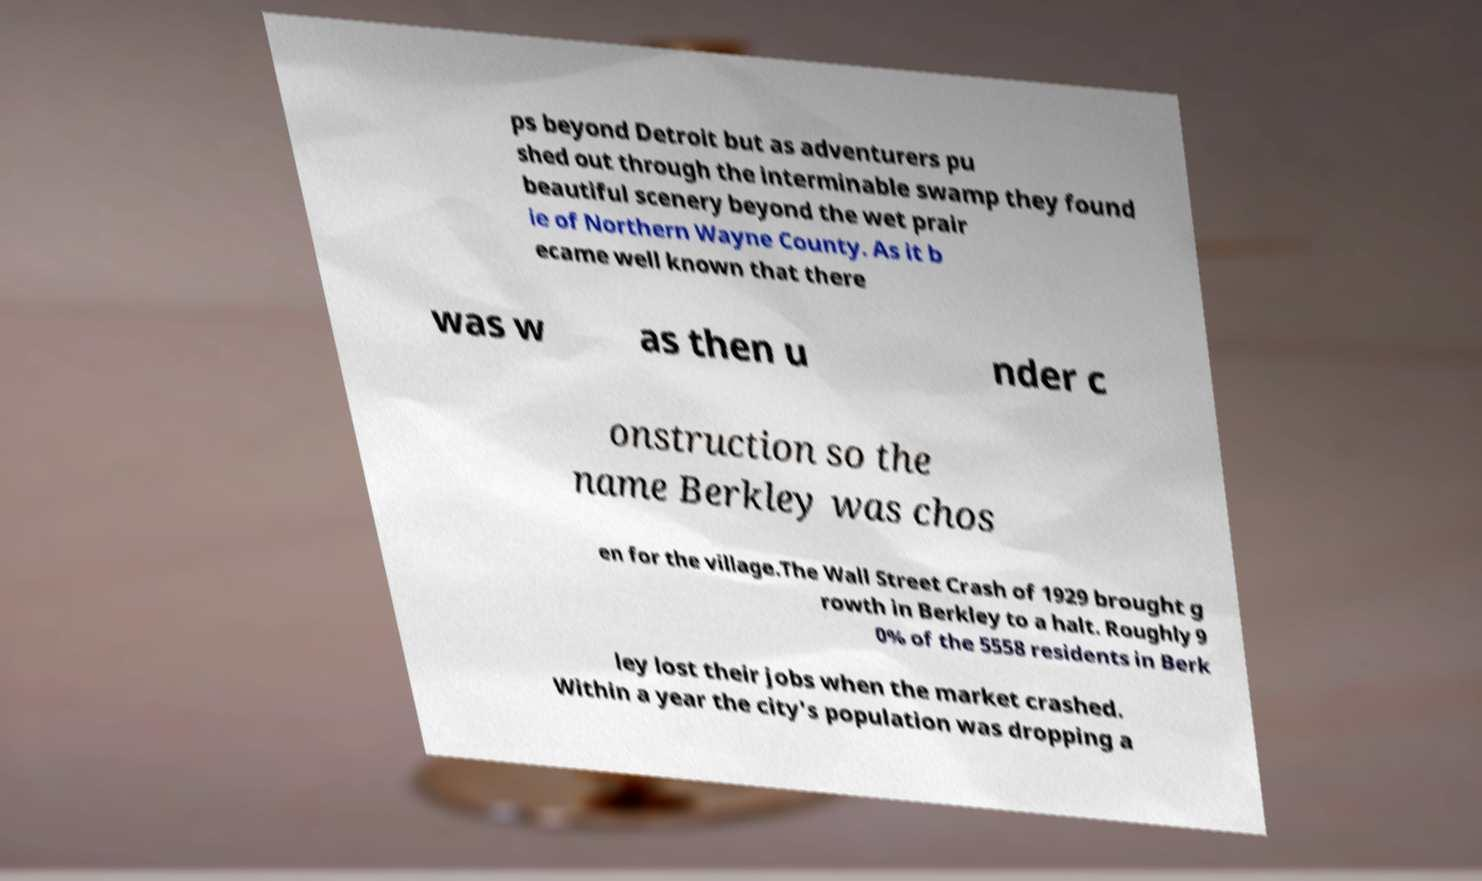Please read and relay the text visible in this image. What does it say? ps beyond Detroit but as adventurers pu shed out through the interminable swamp they found beautiful scenery beyond the wet prair ie of Northern Wayne County. As it b ecame well known that there was w as then u nder c onstruction so the name Berkley was chos en for the village.The Wall Street Crash of 1929 brought g rowth in Berkley to a halt. Roughly 9 0% of the 5558 residents in Berk ley lost their jobs when the market crashed. Within a year the city's population was dropping a 